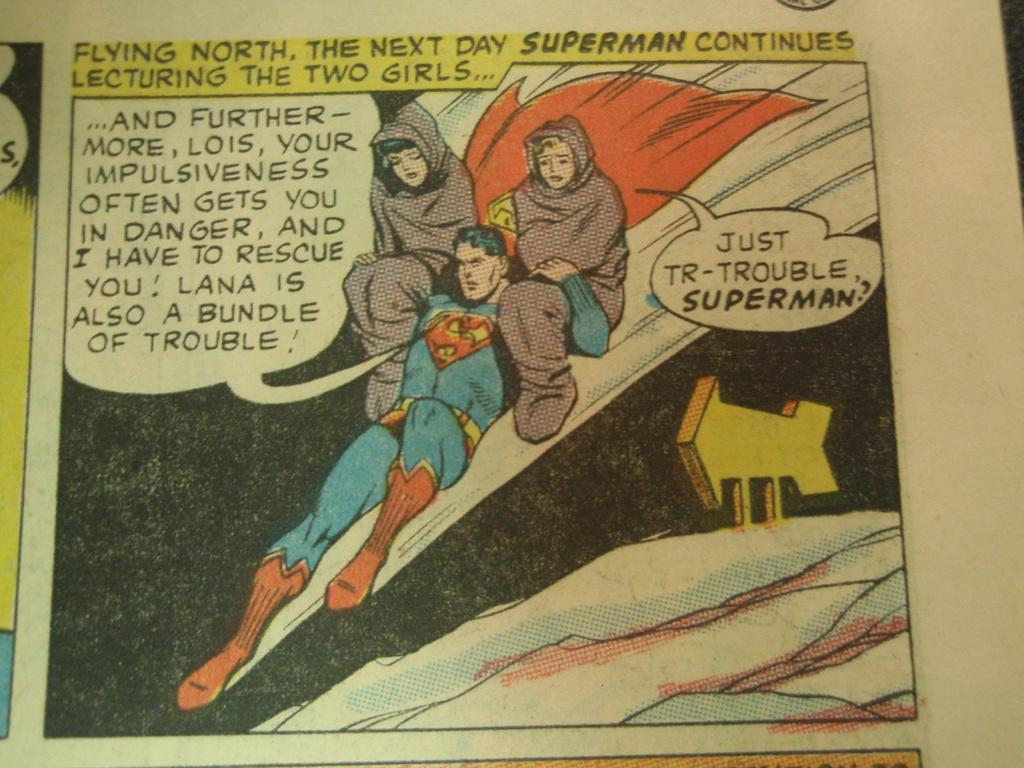<image>
Share a concise interpretation of the image provided. A comic strip shows Superman lecturing Lois and Lana. 